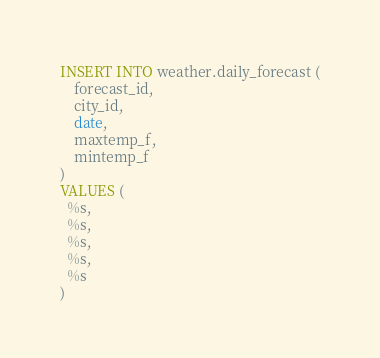Convert code to text. <code><loc_0><loc_0><loc_500><loc_500><_SQL_>INSERT INTO weather.daily_forecast (
    forecast_id,
    city_id,
    date,
    maxtemp_f,
    mintemp_f
)
VALUES (
  %s,  
  %s,
  %s,
  %s,
  %s
)
</code> 